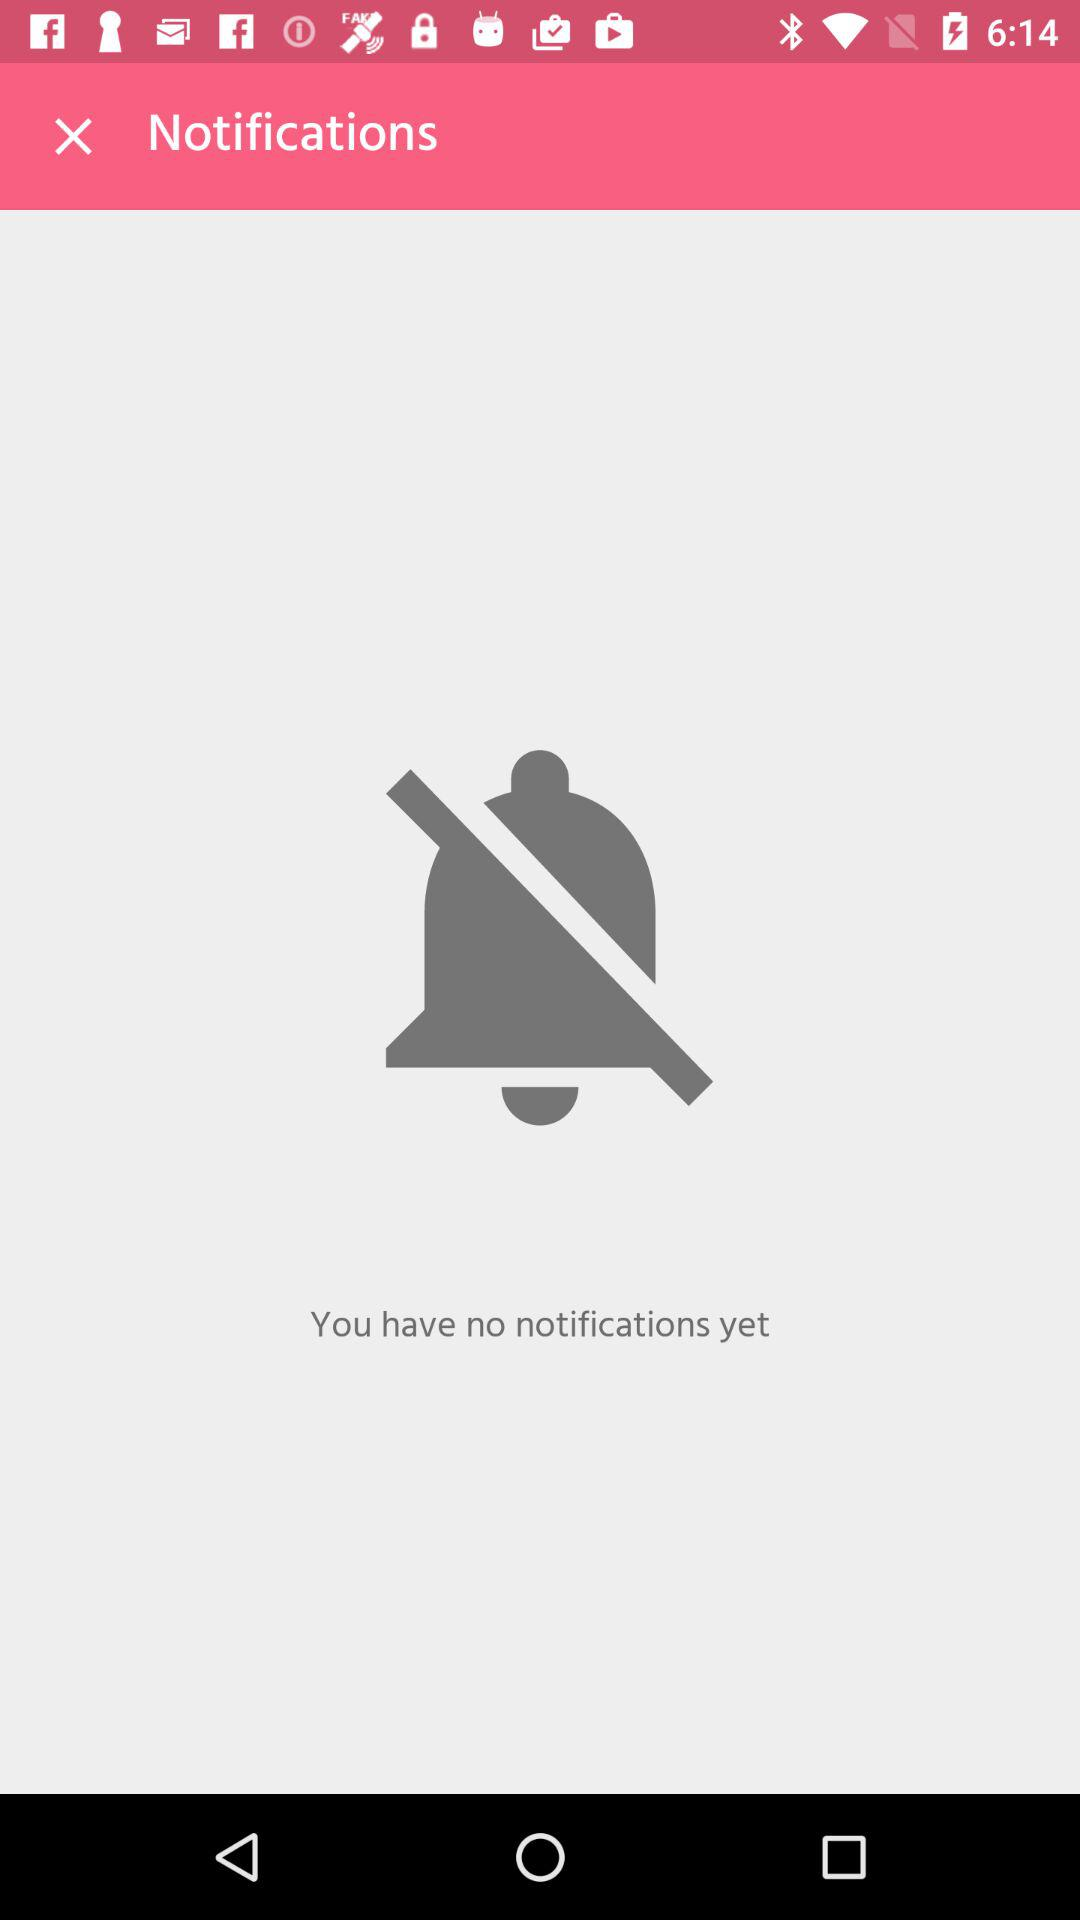How many notifications do I have?
Answer the question using a single word or phrase. 0 